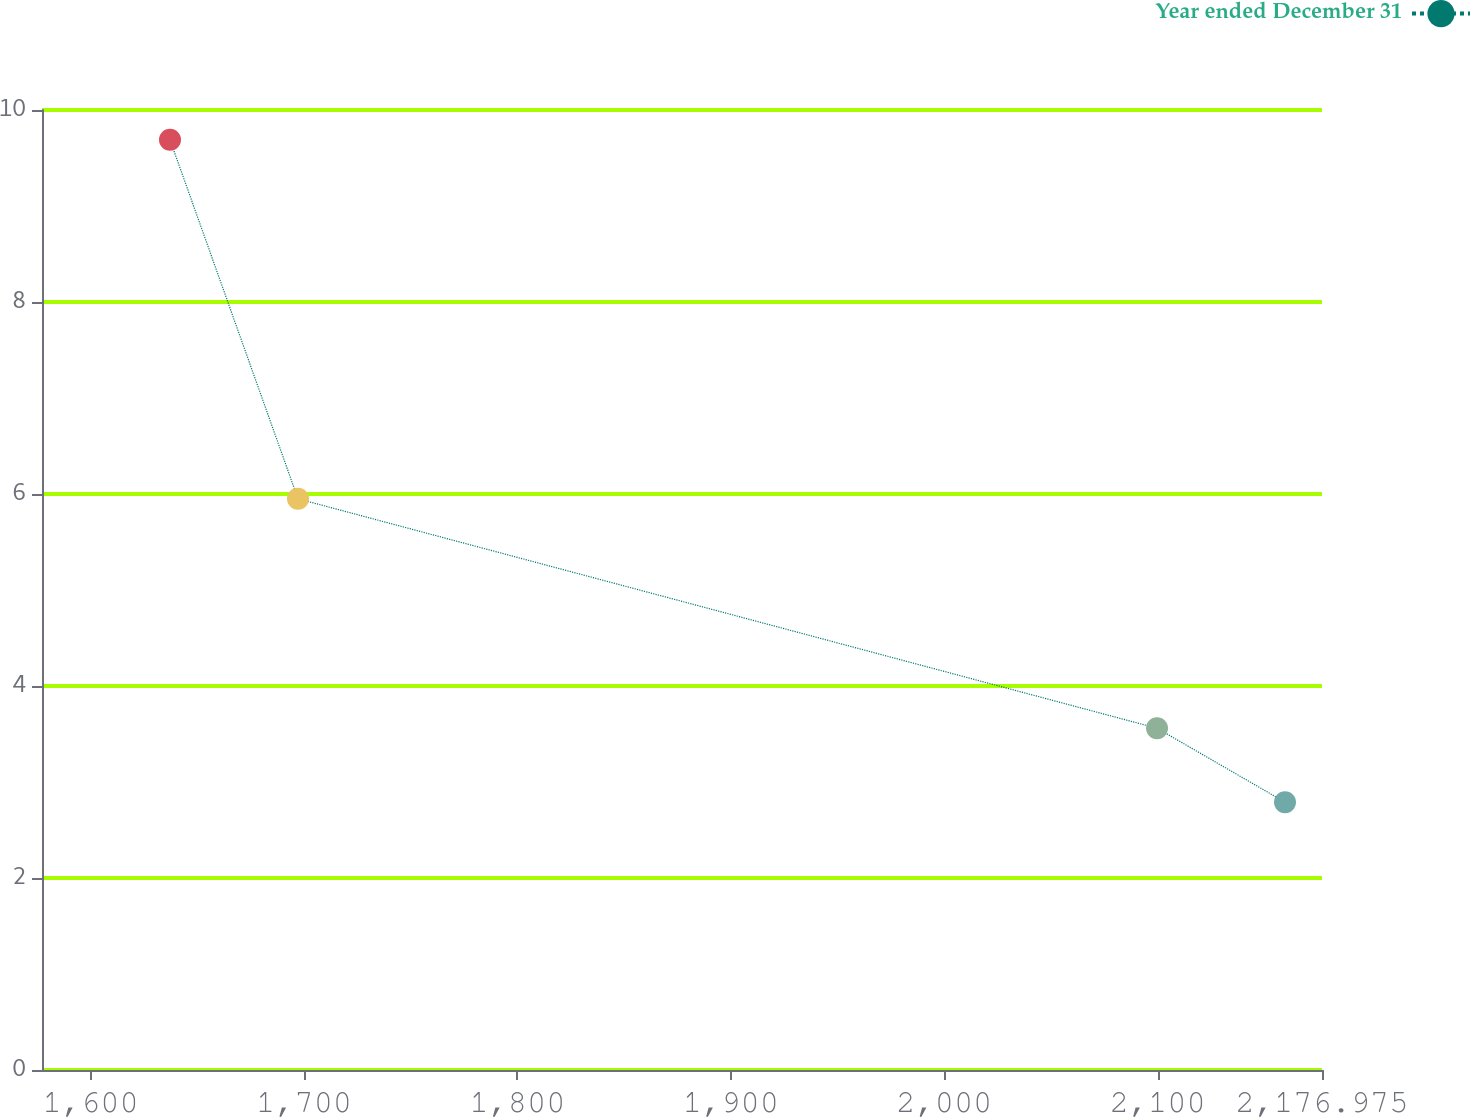Convert chart. <chart><loc_0><loc_0><loc_500><loc_500><line_chart><ecel><fcel>Year ended December 31<nl><fcel>1637.2<fcel>9.69<nl><fcel>1697.17<fcel>5.95<nl><fcel>2099.67<fcel>3.56<nl><fcel>2159.64<fcel>2.79<nl><fcel>2236.95<fcel>2.02<nl></chart> 